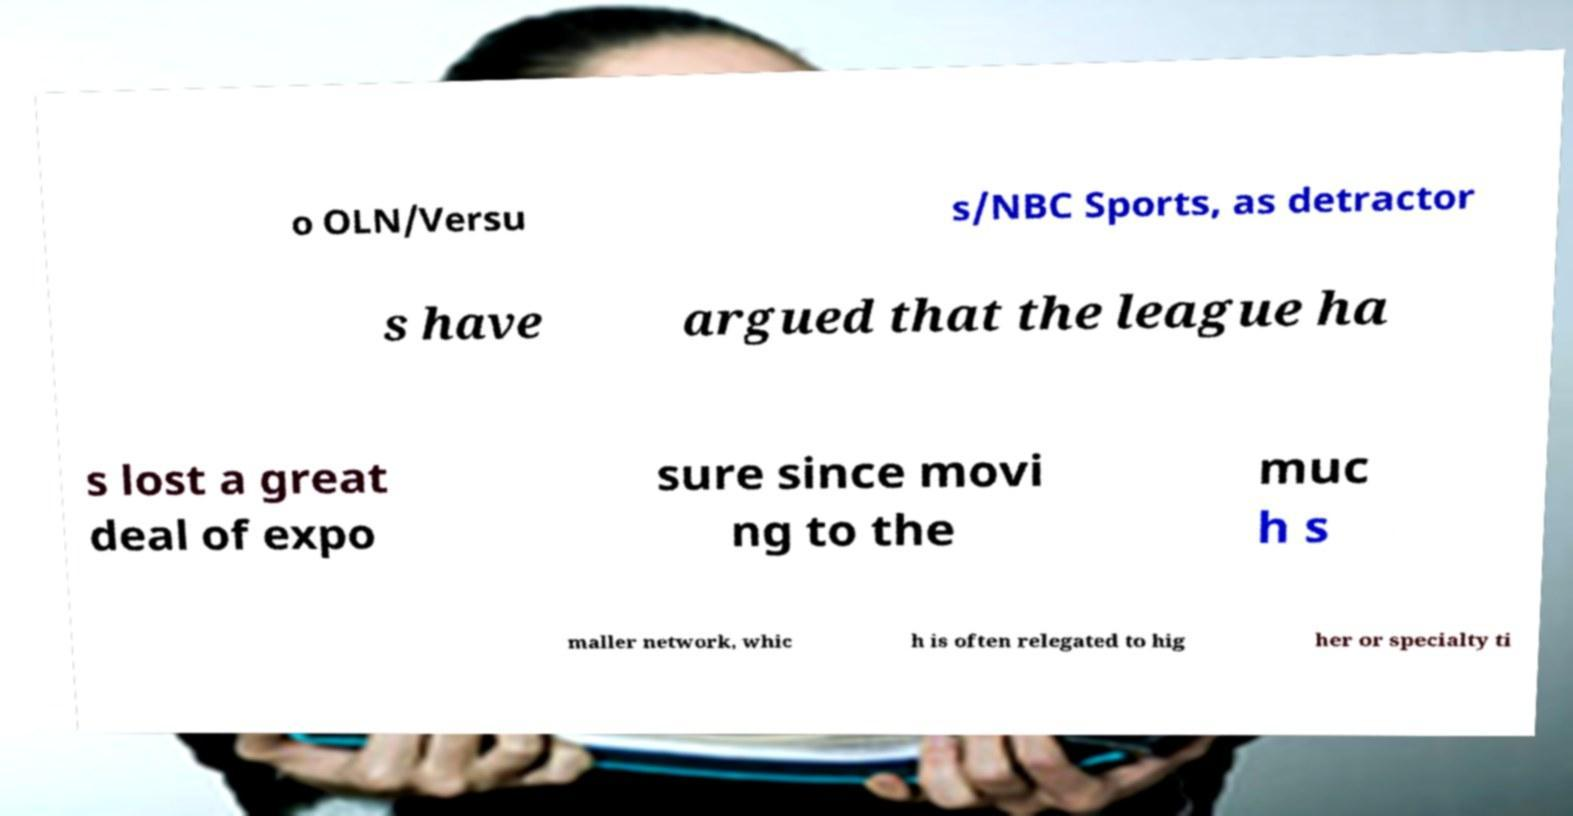I need the written content from this picture converted into text. Can you do that? o OLN/Versu s/NBC Sports, as detractor s have argued that the league ha s lost a great deal of expo sure since movi ng to the muc h s maller network, whic h is often relegated to hig her or specialty ti 